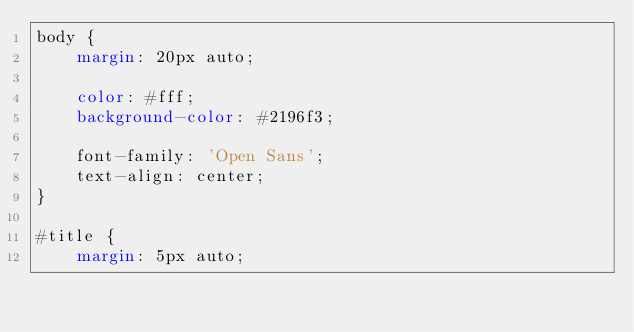Convert code to text. <code><loc_0><loc_0><loc_500><loc_500><_CSS_>body {
    margin: 20px auto;

    color: #fff;
    background-color: #2196f3;

    font-family: 'Open Sans';
    text-align: center;
}

#title {
    margin: 5px auto;
</code> 